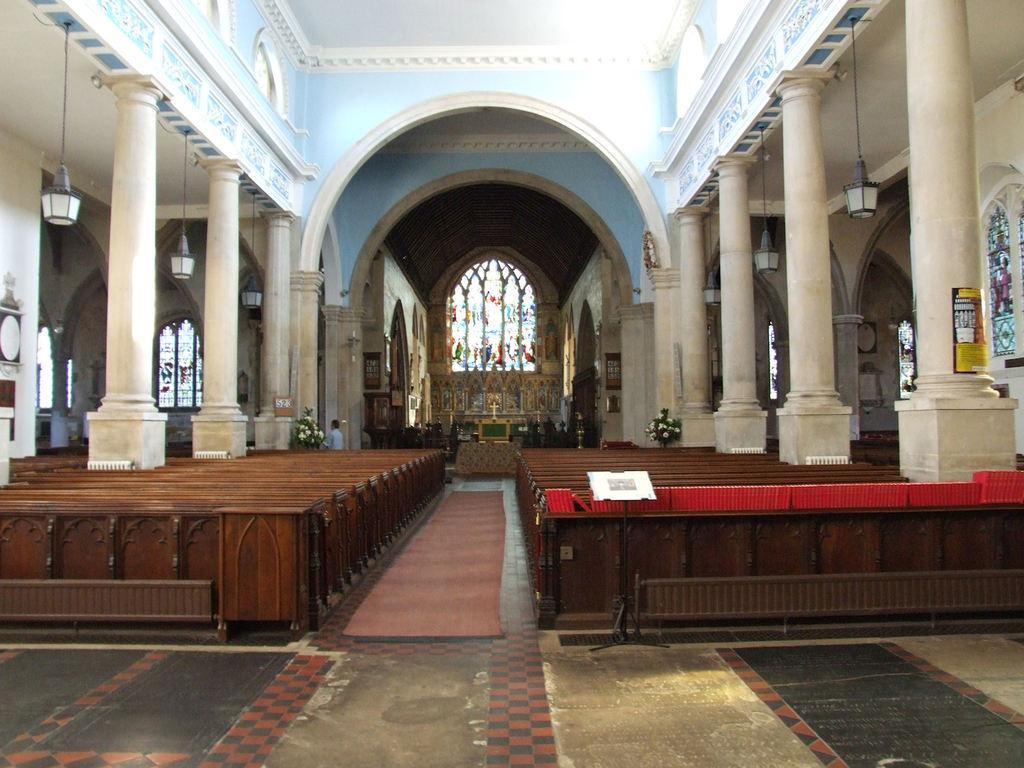Describe this image in one or two sentences. In the picture we can see a church hall with two rows of benches and in the middle of it we can see a mat on the floor and we can also see pillars on the two sides and in the background we can see a table and behind it we can see a glass wall with some colors to it. 